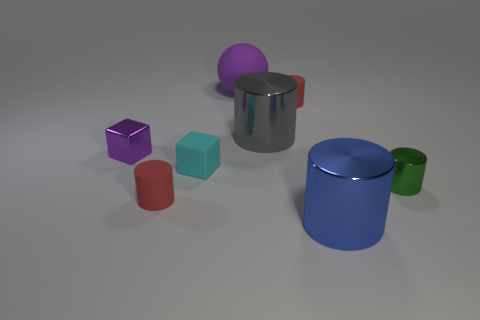Subtract all blue cylinders. How many cylinders are left? 4 Subtract 1 cylinders. How many cylinders are left? 4 Subtract all green shiny cylinders. How many cylinders are left? 4 Subtract all yellow cylinders. Subtract all yellow blocks. How many cylinders are left? 5 Add 1 tiny matte cylinders. How many objects exist? 9 Subtract all blocks. How many objects are left? 6 Subtract all red things. Subtract all rubber cylinders. How many objects are left? 4 Add 2 tiny cyan things. How many tiny cyan things are left? 3 Add 6 purple rubber balls. How many purple rubber balls exist? 7 Subtract 0 purple cylinders. How many objects are left? 8 